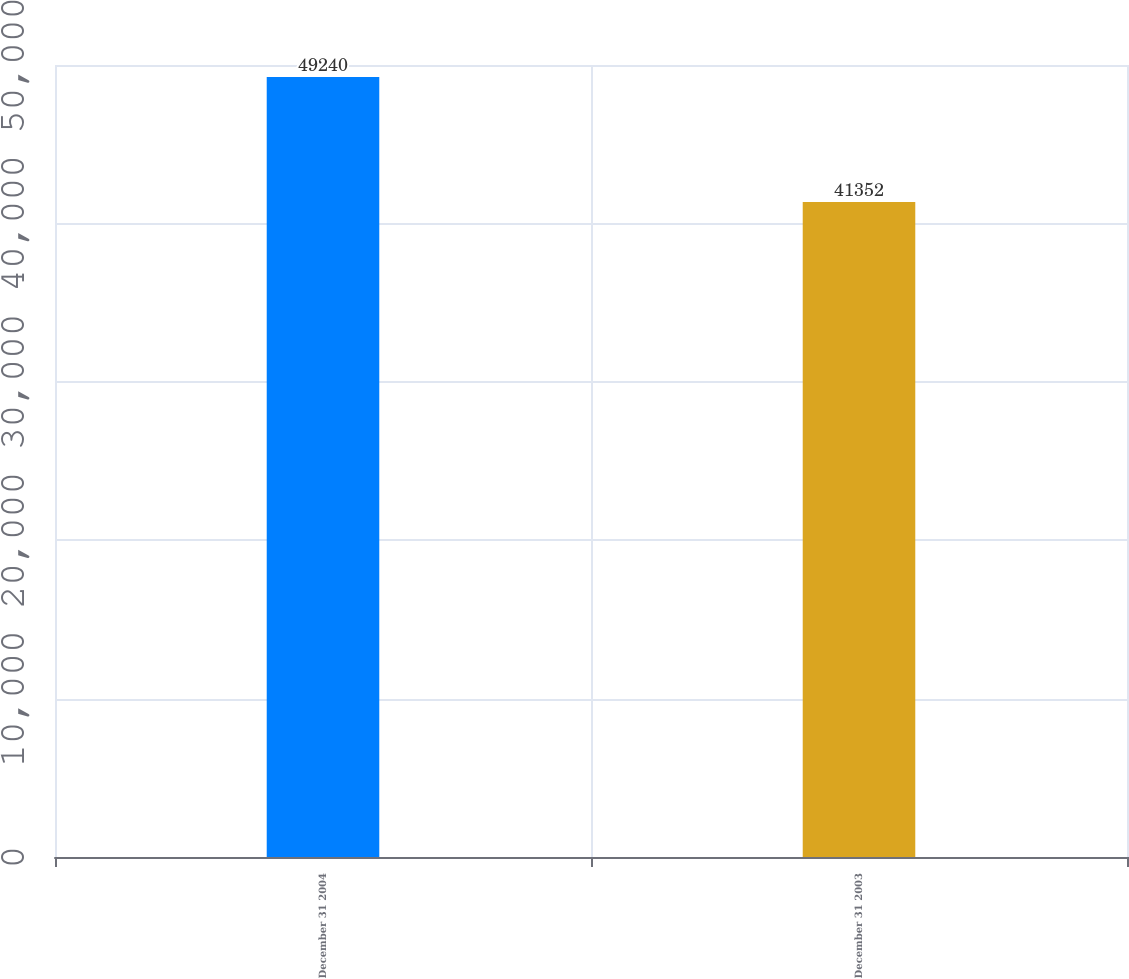<chart> <loc_0><loc_0><loc_500><loc_500><bar_chart><fcel>December 31 2004<fcel>December 31 2003<nl><fcel>49240<fcel>41352<nl></chart> 